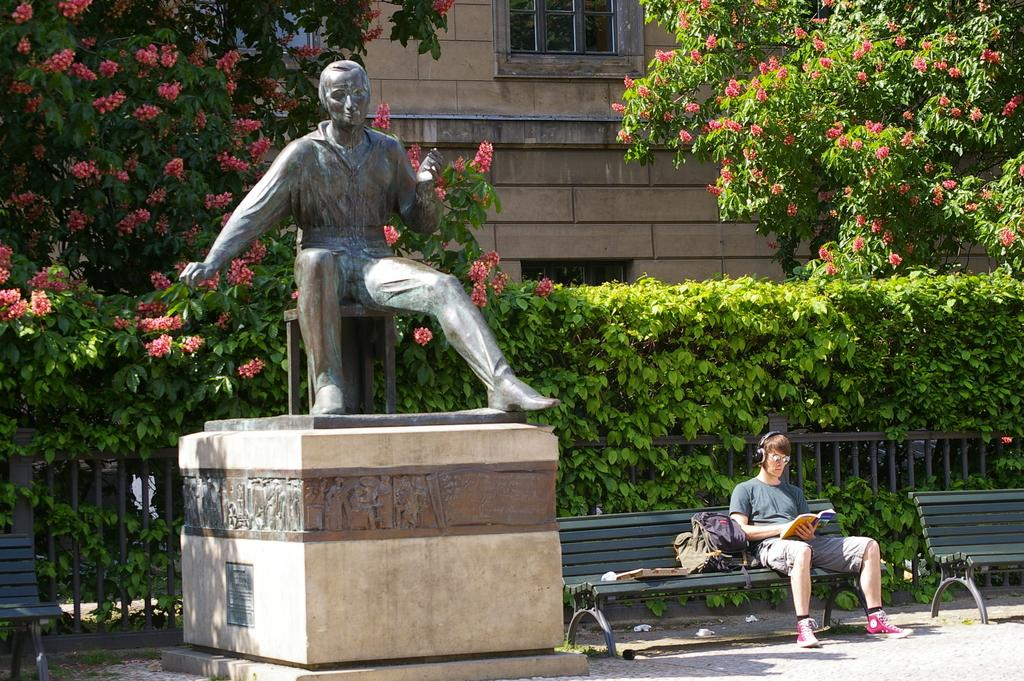What is the main subject in the image? There is a statue in the image. What else can be seen in the image besides the statue? There are benches, a man sitting on a bench, plants, trees, and a building visible in the image. What type of vegetation is present in the image? There are plants and trees visible in the image. Can you describe the structure in the background? There is a building in the image. What type of watch is the kitty wearing in the image? There is no kitty or watch present in the image. 